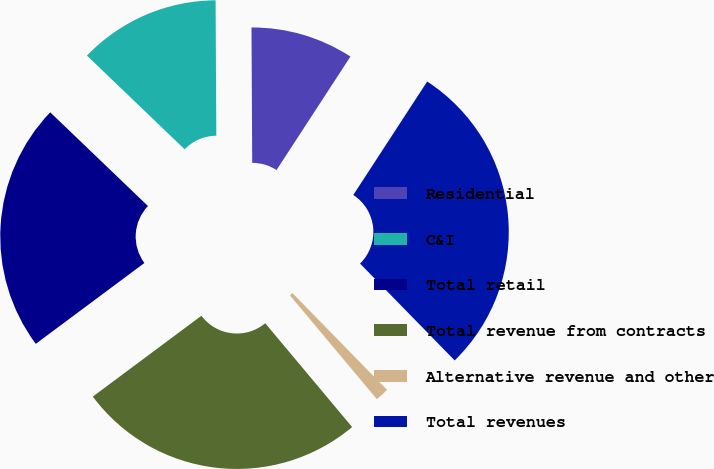Convert chart. <chart><loc_0><loc_0><loc_500><loc_500><pie_chart><fcel>Residential<fcel>C&I<fcel>Total retail<fcel>Total revenue from contracts<fcel>Alternative revenue and other<fcel>Total revenues<nl><fcel>9.27%<fcel>12.75%<fcel>22.35%<fcel>25.91%<fcel>1.22%<fcel>28.5%<nl></chart> 